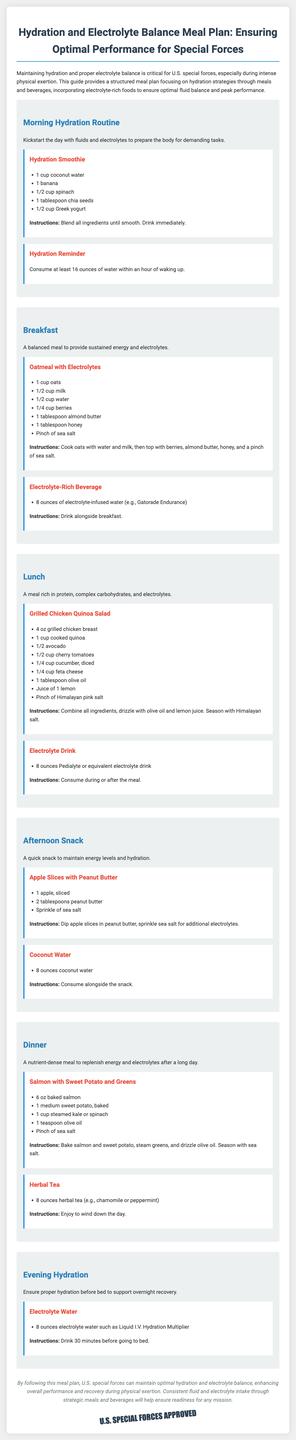what is the title of the meal plan? The title summarizes the document's focus on hydration and electrolyte balance for special forces.
Answer: Hydration and Electrolyte Balance Meal Plan: Ensuring Optimal Performance for Special Forces how many ounces of coconut water are in the hydration smoothie? The hydration smoothie recipe specifies the amount of coconut water required.
Answer: 1 cup what is one of the main ingredients in the grilled chicken quinoa salad? The recipe lists several ingredients for the grilled chicken quinoa salad, with one being highlighted.
Answer: Grilled chicken breast what should be consumed at least an hour after waking up? The meal plan emphasizes the importance of early hydration, specifically mentioning an amount to consume.
Answer: 16 ounces of water what type of beverage is suggested during breakfast? The document provides a specific type of beverage meant to accompany the breakfast meal.
Answer: Electrolyte-infused water what is an ingredient in the dinner meal? The dinner section indicates a nutrient-dense meal with multiple components, including one key ingredient.
Answer: Baked salmon what is the purpose of herbal tea in the meal plan? The meal plan describes the purpose of herbal tea as part of the dinner routine, indicating its role.
Answer: To wind down the day how many tablespoons of chia seeds are used in the hydration smoothie? The hydration smoothie recipe specifies the quantity of chia seeds listed as an ingredient.
Answer: 1 tablespoon what is the recommended drink 30 minutes before bed? The evening hydration section outlines a specific drink to support recovery before sleep.
Answer: Electrolyte water 